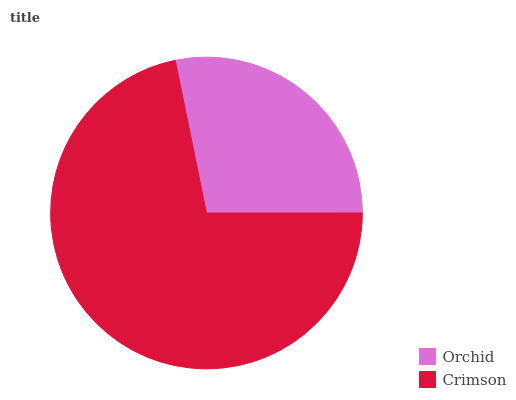Is Orchid the minimum?
Answer yes or no. Yes. Is Crimson the maximum?
Answer yes or no. Yes. Is Crimson the minimum?
Answer yes or no. No. Is Crimson greater than Orchid?
Answer yes or no. Yes. Is Orchid less than Crimson?
Answer yes or no. Yes. Is Orchid greater than Crimson?
Answer yes or no. No. Is Crimson less than Orchid?
Answer yes or no. No. Is Crimson the high median?
Answer yes or no. Yes. Is Orchid the low median?
Answer yes or no. Yes. Is Orchid the high median?
Answer yes or no. No. Is Crimson the low median?
Answer yes or no. No. 